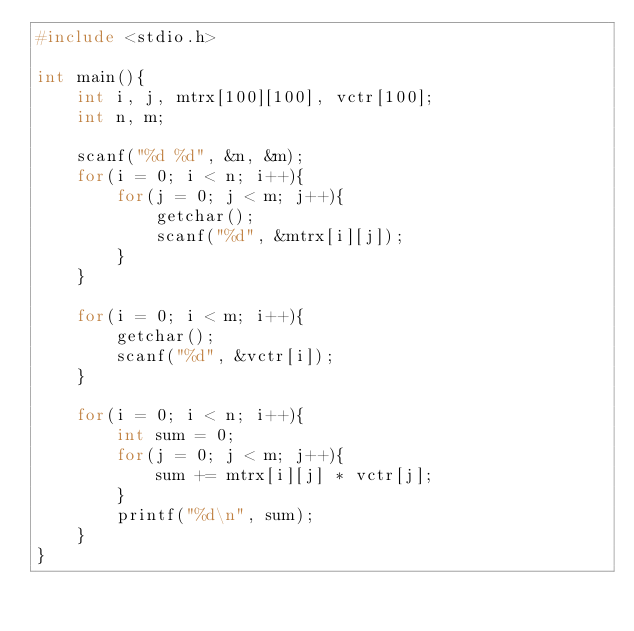Convert code to text. <code><loc_0><loc_0><loc_500><loc_500><_C_>#include <stdio.h>

int main(){
    int i, j, mtrx[100][100], vctr[100];
    int n, m;

    scanf("%d %d", &n, &m);
    for(i = 0; i < n; i++){
        for(j = 0; j < m; j++){
            getchar();
            scanf("%d", &mtrx[i][j]);
        }
    }
    
    for(i = 0; i < m; i++){
        getchar();
        scanf("%d", &vctr[i]);
    }

    for(i = 0; i < n; i++){
        int sum = 0;
        for(j = 0; j < m; j++){
            sum += mtrx[i][j] * vctr[j];
        }
        printf("%d\n", sum);
    }
}
</code> 